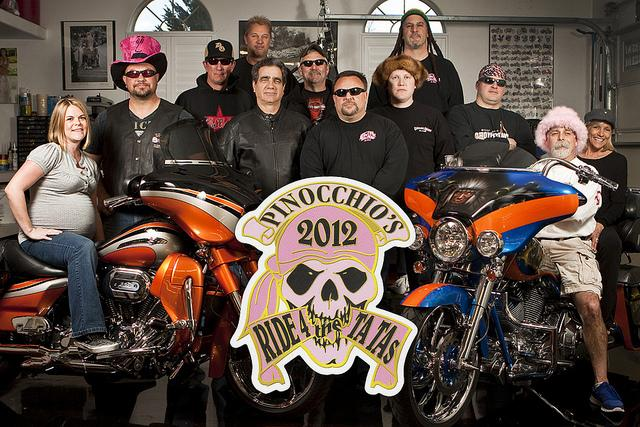What type of cancer charity are they supporting?

Choices:
A) lung
B) breast
C) liver
D) pancreatic breast 